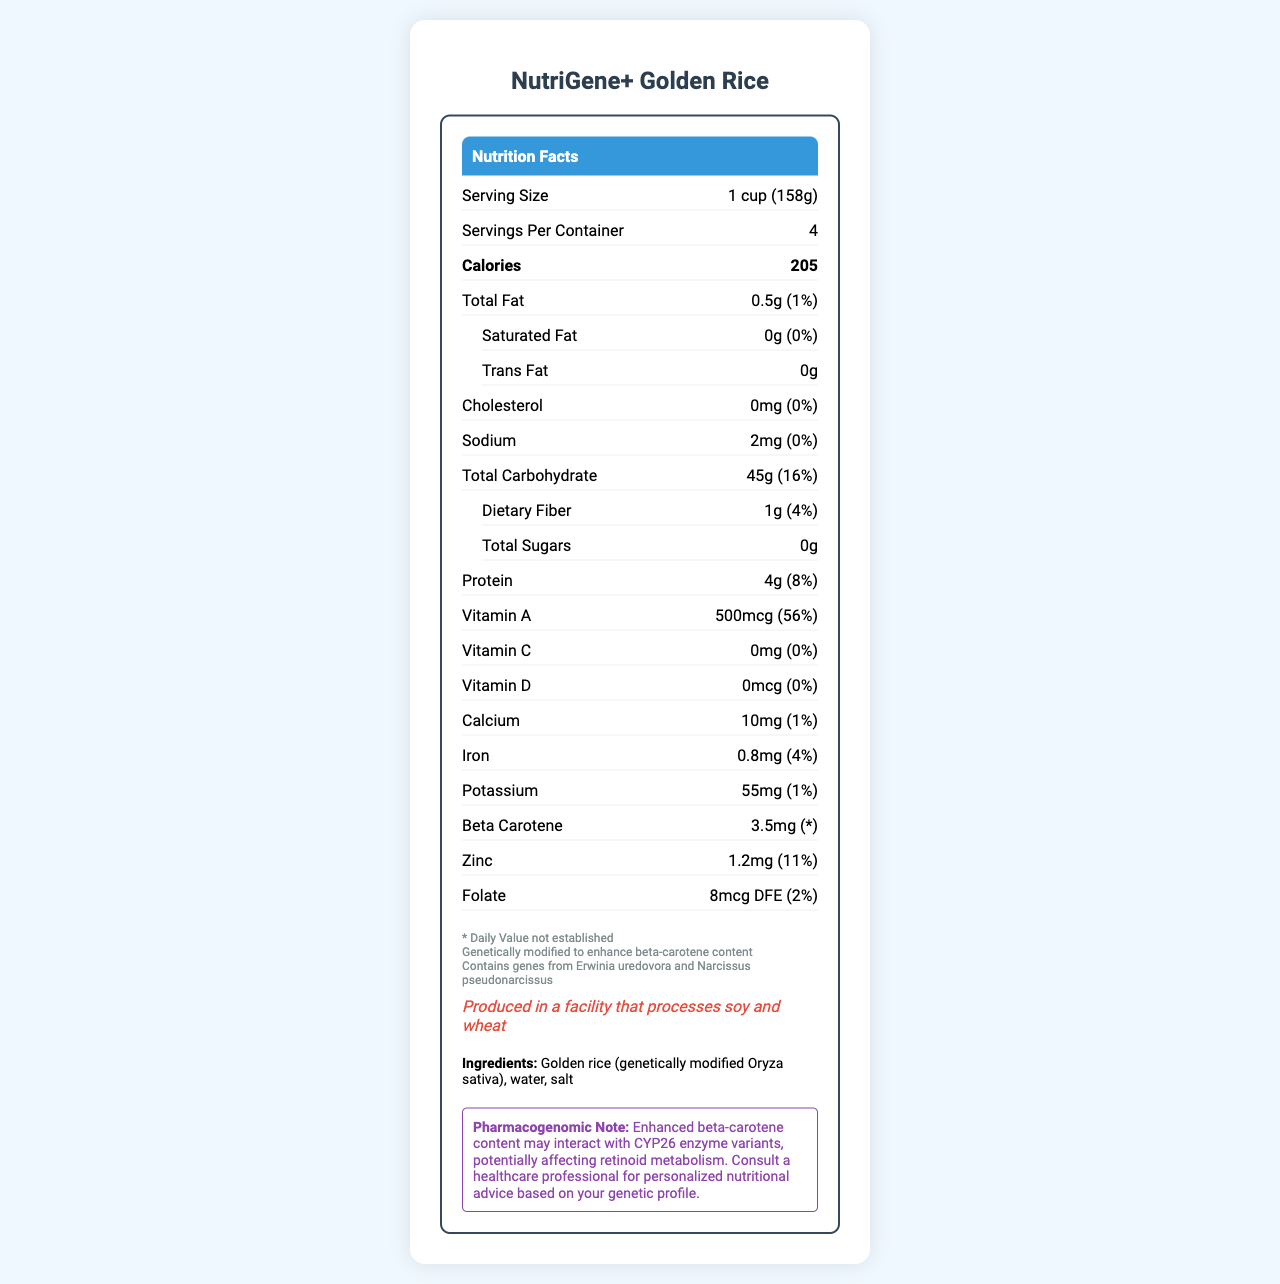what is the serving size for this product? The document explicitly states that the serving size is 1 cup (158g).
Answer: 1 cup (158g) how many servings are contained in one package? The document mentions that there are 4 servings per container.
Answer: 4 how many calories are in one serving? The document lists the calorie content per serving as 205.
Answer: 205 what percentage of the daily value for vitamin A does one serving provide? The document states that one serving provides 56% of the daily value for vitamin A.
Answer: 56% what is the total amount of carbohydrates in one serving? The total carbohydrate content for one serving is listed as 45g.
Answer: 45g which nutrient is genetically enhanced in this product? The additional information section indicates that the product is genetically modified to enhance beta-carotene content.
Answer: Beta-carotene what is the daily value percentage for iron? A. 1% B. 4% C. 8% D. 10% The daily value percentage for iron is listed as 4% in the document.
Answer: B. 4% how much zinc does one serving contain? A. 1mg B. 1.2mg C. 2mg D. 0.8mg The document states that one serving contains 1.2mg of zinc.
Answer: B. 1.2mg does this product contain any trans fats? The document states the trans fat content as 0g.
Answer: No is this product allergen-free? The document notes that the product is produced in a facility that processes soy and wheat.
Answer: No can the serving size in grams be adjusted based on individual dietary needs? The document does not provide any information on adjusting the serving size based on individual dietary needs.
Answer: Cannot be determined summarize the main nutritional and genetic characteristics of NutriGene+ Golden Rice. The summary combines information from various sections, including serving size, calories, fat, carbohydrates, vitamin content, genetic enhancement, allergen information, and pharmacogenomic note.
Answer: NutriGene+ Golden Rice is a genetically modified product designed to enhance beta-carotene content. Each serving size is 1 cup (158g) with 205 calories. It contains small amounts of fat, cholesterol, and sodium, and is a good source of carbohydrate, providing 45g per serving. The product provides significant vitamin A (56% DV) and zinc (11% DV) and is produced in a facility that processes soy and wheat. Be aware of the beta-carotene content's interaction with certain genetic enzymes, potentially affecting retinoid metabolism. 